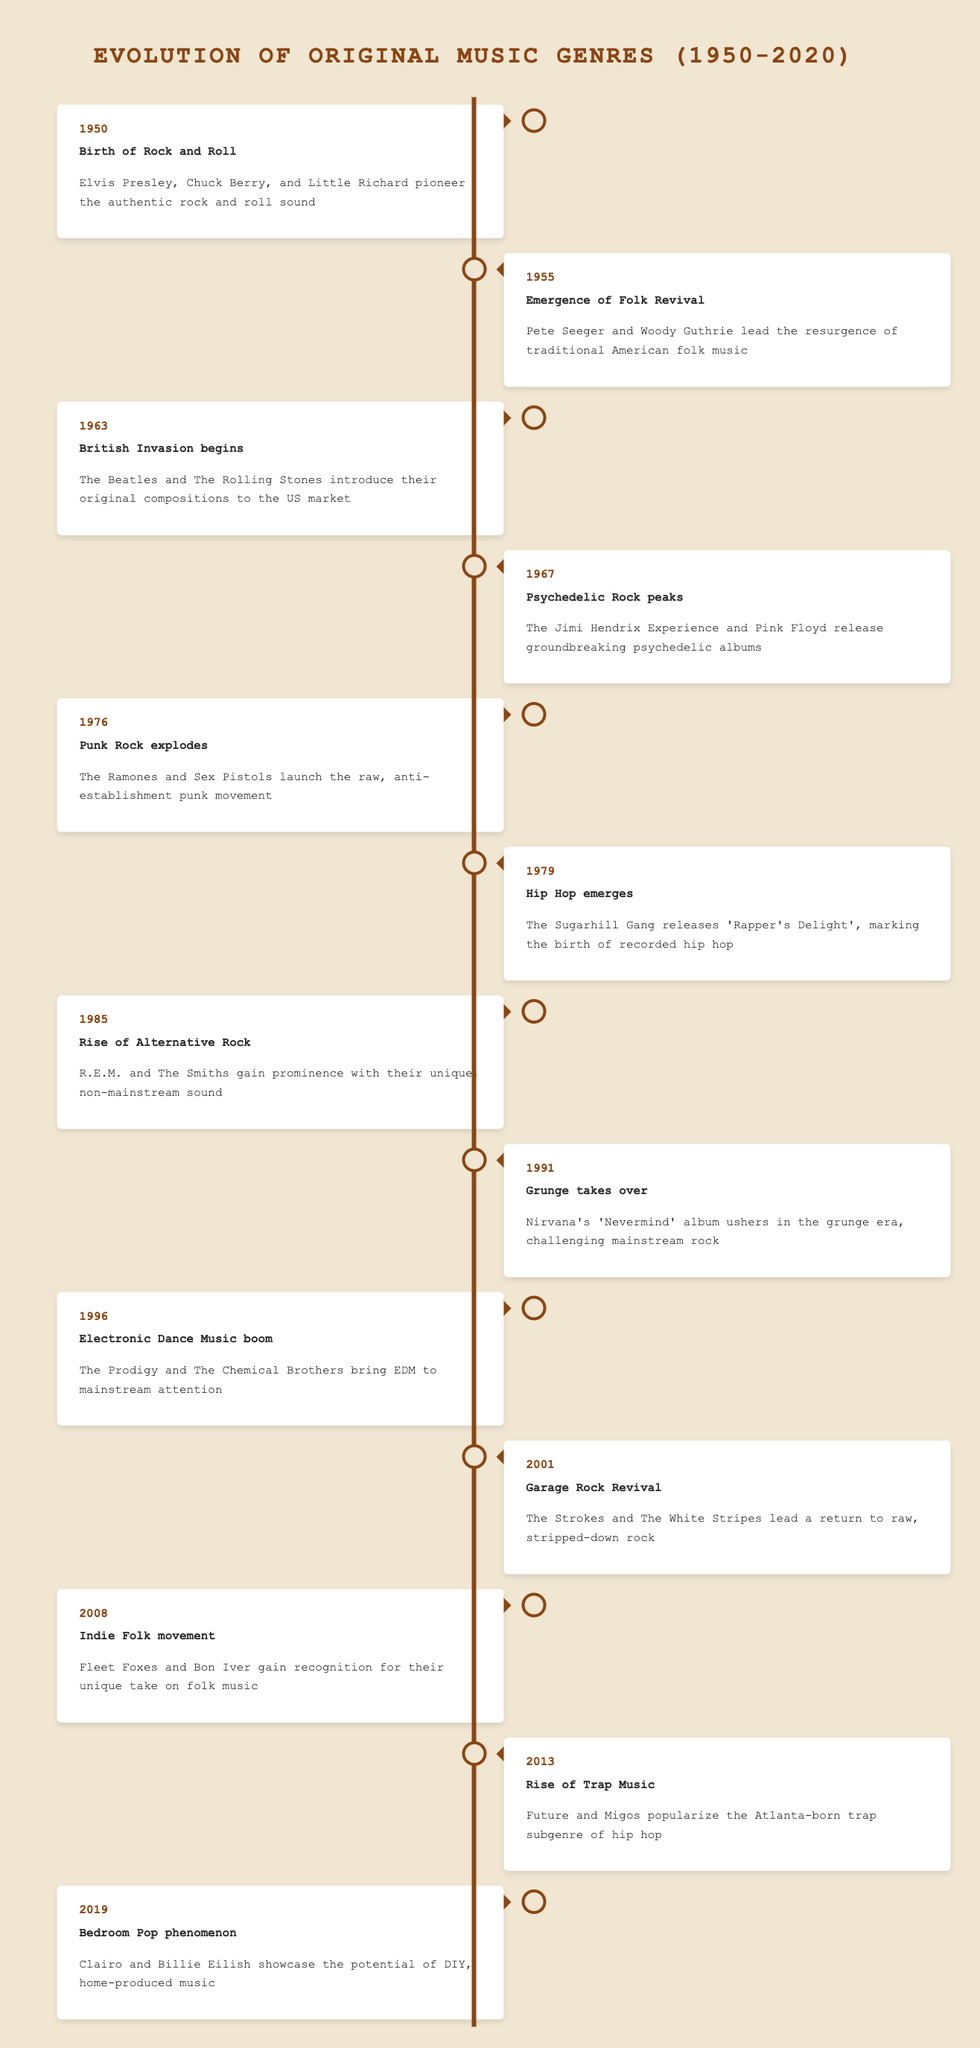What event marked the emergence of Hip Hop? The table indicates that the emergence of Hip Hop occurred in 1979, when The Sugarhill Gang released "Rapper's Delight." This is a direct retrieval from the timeline's event descriptions.
Answer: Hip Hop emerges In what year did Punk Rock explode? According to the timeline, Punk Rock exploded in 1976, as stated in the description of the corresponding event. This can be found easily in the table without any calculations or combinations.
Answer: 1976 Which genre was popularized in 2013? The table shows that the genre popularized in 2013 was Trap Music, highlighted in the event description. This is straightforward to find in the timeline.
Answer: Trap Music How many distinct music genres are referenced in this timeline? The timeline includes 14 distinct music genres, each associated with specific events throughout the years. A careful count of each unique genre mentioned will yield this total.
Answer: 14 Was the release of "Nevermind" significant for the Grunge genre? Yes, the timeline notes that Nirvana's album "Nevermind" played a crucial role in ushering in the grunge era, indicating its significance for that genre.
Answer: Yes Identify the two artists associated with the birth of Rock and Roll. The timeline indicates that Elvis Presley, Chuck Berry, and Little Richard were the pioneers of Rock and Roll, but the question specifically asks for two artists. Thus, any two can be named from these three.
Answer: Elvis Presley and Chuck Berry What is the difference in years between the emergence of Hip Hop and the birth of Rock and Roll? The emergence of Hip Hop is noted in 1979, while the birth of Rock and Roll began in 1950. The difference can be calculated: 1979 - 1950 = 29 years. This involves performing a simple subtraction operation.
Answer: 29 years Which genre originated in the 1960s and what was its peak year? Based on the timeline, the British Invasion began in 1963, while Psychedelic Rock peaked in 1967. The question is asking for both a time frame and an event, which are found sequentially in the timeline.
Answer: British Invasion, 1963; Psychedelic Rock, 1967 Does the table list any genres specifically emerging after 2000? Yes, the timeline indicates that both Garage Rock Revival in 2001 and Bedroom Pop in 2019 emerged after 2000. This requires checking multiple entries in the timeline to confirm.
Answer: Yes 